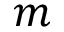Convert formula to latex. <formula><loc_0><loc_0><loc_500><loc_500>m</formula> 